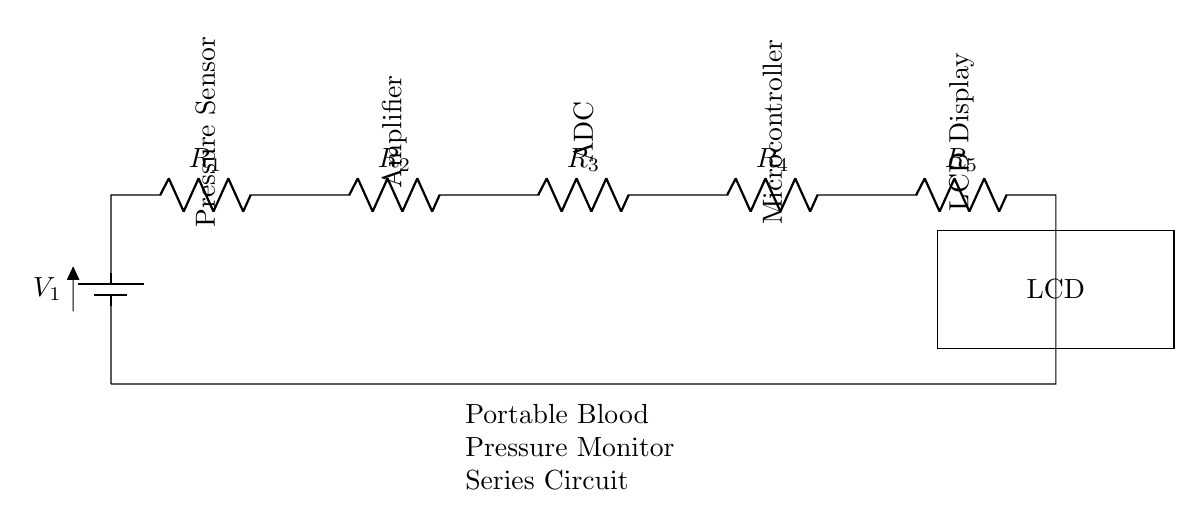What is the primary power source in this circuit? The primary power source is the battery, denoted as 'V1' in the diagram, which supplies voltage to the components of the circuit.
Answer: battery How many resistors are present in the circuit? The circuit diagram shows five resistors labeled 'R1' through 'R5' connected in series. Counting these gives a total of five resistors.
Answer: five What type of circuit is depicted in the diagram? The components are connected in a single path without any branching, indicating that this is a series circuit.
Answer: series circuit Which component regulates the blood pressure readings? The pressure sensor is the component that detects and regulates the blood pressure readings, as indicated in the diagram.
Answer: pressure sensor What follows the ADC in the circuit? After the ADC (Analog to Digital Converter), the microcontroller is the next component in the sequence, processing the data received.
Answer: microcontroller What is the function of the LCD Display in this circuit? The LCD Display presents the processed blood pressure measurement data to the user, making it easy to read.
Answer: presents measurement data How does the voltage drop across the resistors affect this circuit? In a series circuit, the total voltage supplied by the battery is divided across all resistors according to their resistance values, which can affect the current flowing through each component.
Answer: divides voltage 